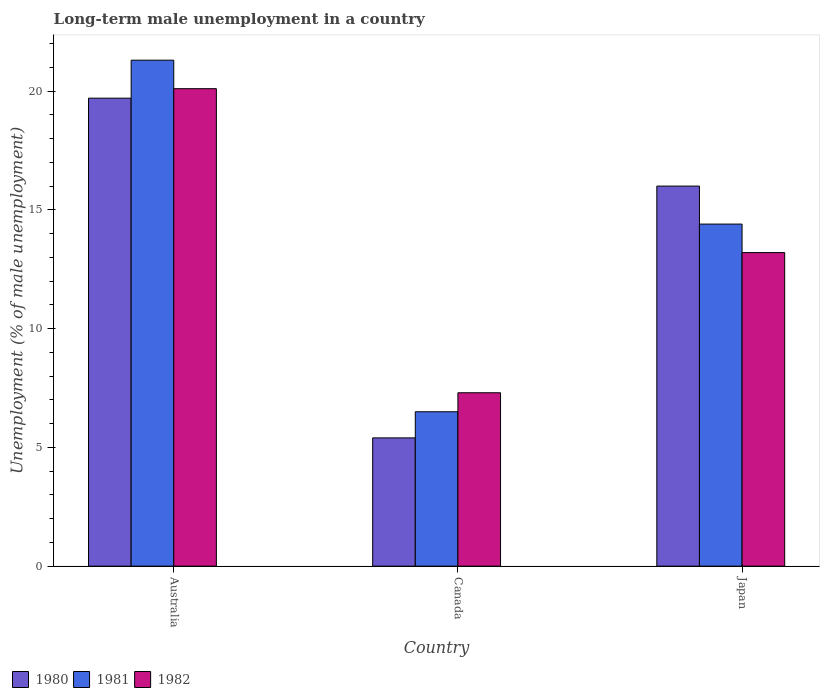How many groups of bars are there?
Make the answer very short. 3. Are the number of bars per tick equal to the number of legend labels?
Your answer should be compact. Yes. What is the label of the 1st group of bars from the left?
Offer a terse response. Australia. In how many cases, is the number of bars for a given country not equal to the number of legend labels?
Offer a very short reply. 0. What is the percentage of long-term unemployed male population in 1982 in Japan?
Provide a short and direct response. 13.2. Across all countries, what is the maximum percentage of long-term unemployed male population in 1982?
Provide a succinct answer. 20.1. Across all countries, what is the minimum percentage of long-term unemployed male population in 1981?
Your answer should be very brief. 6.5. In which country was the percentage of long-term unemployed male population in 1982 maximum?
Ensure brevity in your answer.  Australia. In which country was the percentage of long-term unemployed male population in 1982 minimum?
Your answer should be compact. Canada. What is the total percentage of long-term unemployed male population in 1981 in the graph?
Make the answer very short. 42.2. What is the difference between the percentage of long-term unemployed male population in 1982 in Canada and that in Japan?
Your answer should be compact. -5.9. What is the difference between the percentage of long-term unemployed male population in 1980 in Australia and the percentage of long-term unemployed male population in 1982 in Canada?
Keep it short and to the point. 12.4. What is the average percentage of long-term unemployed male population in 1980 per country?
Ensure brevity in your answer.  13.7. What is the difference between the percentage of long-term unemployed male population of/in 1982 and percentage of long-term unemployed male population of/in 1980 in Australia?
Your response must be concise. 0.4. What is the ratio of the percentage of long-term unemployed male population in 1981 in Australia to that in Japan?
Keep it short and to the point. 1.48. Is the difference between the percentage of long-term unemployed male population in 1982 in Australia and Canada greater than the difference between the percentage of long-term unemployed male population in 1980 in Australia and Canada?
Your response must be concise. No. What is the difference between the highest and the second highest percentage of long-term unemployed male population in 1980?
Your response must be concise. -3.7. What is the difference between the highest and the lowest percentage of long-term unemployed male population in 1980?
Give a very brief answer. 14.3. Is it the case that in every country, the sum of the percentage of long-term unemployed male population in 1981 and percentage of long-term unemployed male population in 1980 is greater than the percentage of long-term unemployed male population in 1982?
Your response must be concise. Yes. What is the difference between two consecutive major ticks on the Y-axis?
Your answer should be compact. 5. Where does the legend appear in the graph?
Give a very brief answer. Bottom left. How are the legend labels stacked?
Your answer should be compact. Horizontal. What is the title of the graph?
Your response must be concise. Long-term male unemployment in a country. What is the label or title of the X-axis?
Your response must be concise. Country. What is the label or title of the Y-axis?
Provide a short and direct response. Unemployment (% of male unemployment). What is the Unemployment (% of male unemployment) in 1980 in Australia?
Your answer should be compact. 19.7. What is the Unemployment (% of male unemployment) of 1981 in Australia?
Make the answer very short. 21.3. What is the Unemployment (% of male unemployment) of 1982 in Australia?
Give a very brief answer. 20.1. What is the Unemployment (% of male unemployment) in 1980 in Canada?
Provide a short and direct response. 5.4. What is the Unemployment (% of male unemployment) in 1982 in Canada?
Your answer should be compact. 7.3. What is the Unemployment (% of male unemployment) of 1980 in Japan?
Provide a succinct answer. 16. What is the Unemployment (% of male unemployment) of 1981 in Japan?
Make the answer very short. 14.4. What is the Unemployment (% of male unemployment) in 1982 in Japan?
Ensure brevity in your answer.  13.2. Across all countries, what is the maximum Unemployment (% of male unemployment) in 1980?
Your answer should be very brief. 19.7. Across all countries, what is the maximum Unemployment (% of male unemployment) in 1981?
Provide a succinct answer. 21.3. Across all countries, what is the maximum Unemployment (% of male unemployment) of 1982?
Ensure brevity in your answer.  20.1. Across all countries, what is the minimum Unemployment (% of male unemployment) of 1980?
Ensure brevity in your answer.  5.4. Across all countries, what is the minimum Unemployment (% of male unemployment) of 1982?
Your answer should be compact. 7.3. What is the total Unemployment (% of male unemployment) of 1980 in the graph?
Your answer should be very brief. 41.1. What is the total Unemployment (% of male unemployment) in 1981 in the graph?
Your answer should be compact. 42.2. What is the total Unemployment (% of male unemployment) of 1982 in the graph?
Your answer should be compact. 40.6. What is the difference between the Unemployment (% of male unemployment) in 1980 in Australia and that in Japan?
Make the answer very short. 3.7. What is the difference between the Unemployment (% of male unemployment) in 1980 in Canada and that in Japan?
Your answer should be very brief. -10.6. What is the difference between the Unemployment (% of male unemployment) of 1981 in Canada and that in Japan?
Offer a very short reply. -7.9. What is the difference between the Unemployment (% of male unemployment) in 1982 in Canada and that in Japan?
Your answer should be very brief. -5.9. What is the difference between the Unemployment (% of male unemployment) of 1981 in Australia and the Unemployment (% of male unemployment) of 1982 in Japan?
Offer a very short reply. 8.1. What is the difference between the Unemployment (% of male unemployment) in 1980 in Canada and the Unemployment (% of male unemployment) in 1981 in Japan?
Provide a short and direct response. -9. What is the average Unemployment (% of male unemployment) in 1980 per country?
Keep it short and to the point. 13.7. What is the average Unemployment (% of male unemployment) of 1981 per country?
Your response must be concise. 14.07. What is the average Unemployment (% of male unemployment) in 1982 per country?
Offer a terse response. 13.53. What is the difference between the Unemployment (% of male unemployment) of 1980 and Unemployment (% of male unemployment) of 1981 in Australia?
Your answer should be compact. -1.6. What is the difference between the Unemployment (% of male unemployment) of 1980 and Unemployment (% of male unemployment) of 1982 in Australia?
Provide a succinct answer. -0.4. What is the difference between the Unemployment (% of male unemployment) of 1980 and Unemployment (% of male unemployment) of 1981 in Canada?
Keep it short and to the point. -1.1. What is the difference between the Unemployment (% of male unemployment) of 1980 and Unemployment (% of male unemployment) of 1982 in Canada?
Offer a terse response. -1.9. What is the difference between the Unemployment (% of male unemployment) in 1981 and Unemployment (% of male unemployment) in 1982 in Canada?
Your answer should be very brief. -0.8. What is the difference between the Unemployment (% of male unemployment) of 1981 and Unemployment (% of male unemployment) of 1982 in Japan?
Your answer should be compact. 1.2. What is the ratio of the Unemployment (% of male unemployment) of 1980 in Australia to that in Canada?
Provide a short and direct response. 3.65. What is the ratio of the Unemployment (% of male unemployment) of 1981 in Australia to that in Canada?
Provide a short and direct response. 3.28. What is the ratio of the Unemployment (% of male unemployment) in 1982 in Australia to that in Canada?
Your answer should be compact. 2.75. What is the ratio of the Unemployment (% of male unemployment) of 1980 in Australia to that in Japan?
Offer a very short reply. 1.23. What is the ratio of the Unemployment (% of male unemployment) in 1981 in Australia to that in Japan?
Offer a very short reply. 1.48. What is the ratio of the Unemployment (% of male unemployment) of 1982 in Australia to that in Japan?
Keep it short and to the point. 1.52. What is the ratio of the Unemployment (% of male unemployment) in 1980 in Canada to that in Japan?
Your answer should be very brief. 0.34. What is the ratio of the Unemployment (% of male unemployment) of 1981 in Canada to that in Japan?
Your answer should be compact. 0.45. What is the ratio of the Unemployment (% of male unemployment) of 1982 in Canada to that in Japan?
Offer a terse response. 0.55. What is the difference between the highest and the second highest Unemployment (% of male unemployment) of 1982?
Provide a succinct answer. 6.9. What is the difference between the highest and the lowest Unemployment (% of male unemployment) in 1980?
Ensure brevity in your answer.  14.3. 